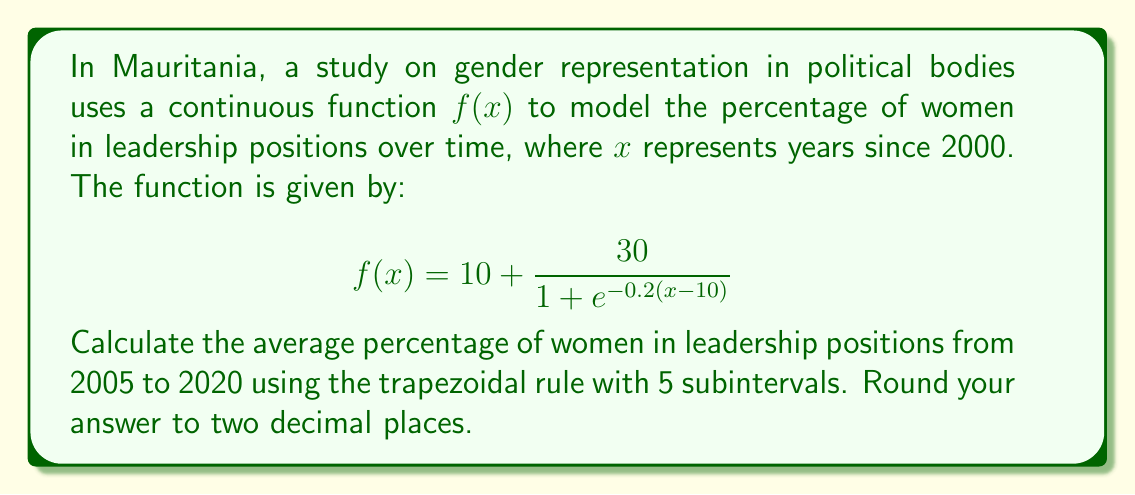What is the answer to this math problem? To solve this problem, we'll use the trapezoidal rule for numerical integration:

1) The trapezoidal rule is given by:
   $$\int_a^b f(x)dx \approx \frac{h}{2}[f(a) + 2f(x_1) + 2f(x_2) + ... + 2f(x_{n-1}) + f(b)]$$
   where $h = \frac{b-a}{n}$, and $n$ is the number of subintervals.

2) In our case:
   $a = 5$ (2005 is 5 years after 2000)
   $b = 20$ (2020 is 20 years after 2000)
   $n = 5$ (5 subintervals)

3) Calculate $h$:
   $h = \frac{20-5}{5} = 3$

4) Calculate the $x$ values:
   $x_0 = 5, x_1 = 8, x_2 = 11, x_3 = 14, x_4 = 17, x_5 = 20$

5) Calculate $f(x)$ for each $x$ value:
   $f(5) = 10 + \frac{30}{1 + e^{-0.2(5-10)}} = 15.62$
   $f(8) = 10 + \frac{30}{1 + e^{-0.2(8-10)}} = 19.49$
   $f(11) = 10 + \frac{30}{1 + e^{-0.2(11-10)}} = 25.00$
   $f(14) = 10 + \frac{30}{1 + e^{-0.2(14-10)}} = 30.51$
   $f(17) = 10 + \frac{30}{1 + e^{-0.2(17-10)}} = 34.38$
   $f(20) = 10 + \frac{30}{1 + e^{-0.2(20-10)}} = 36.76$

6) Apply the trapezoidal rule:
   $$\int_5^{20} f(x)dx \approx \frac{3}{2}[15.62 + 2(19.49 + 25.00 + 30.51 + 34.38) + 36.76]$$
   $$= \frac{3}{2}[15.62 + 218.76 + 36.76] = 203.85$$

7) To get the average, divide by the interval length (15 years):
   Average = $\frac{203.85}{15} = 13.59$
Answer: 13.59% 